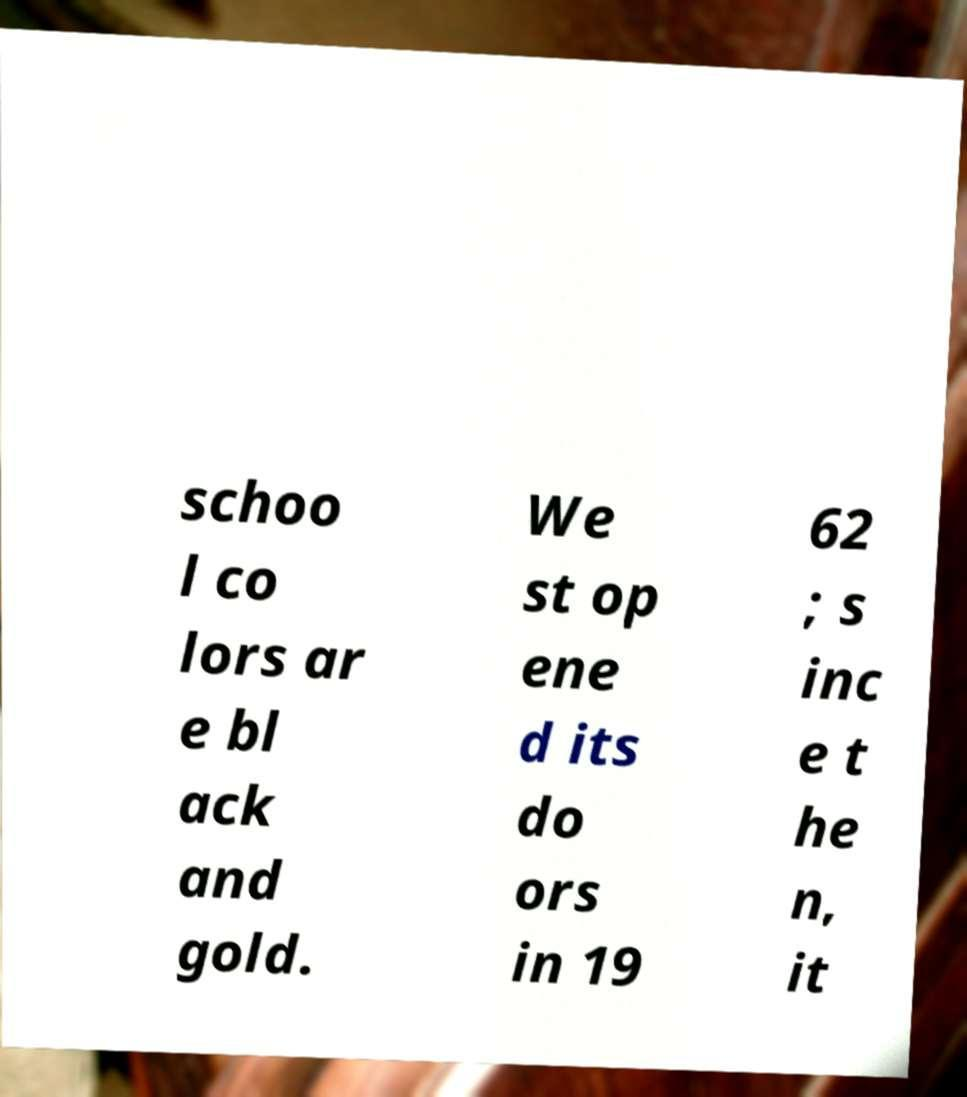I need the written content from this picture converted into text. Can you do that? schoo l co lors ar e bl ack and gold. We st op ene d its do ors in 19 62 ; s inc e t he n, it 